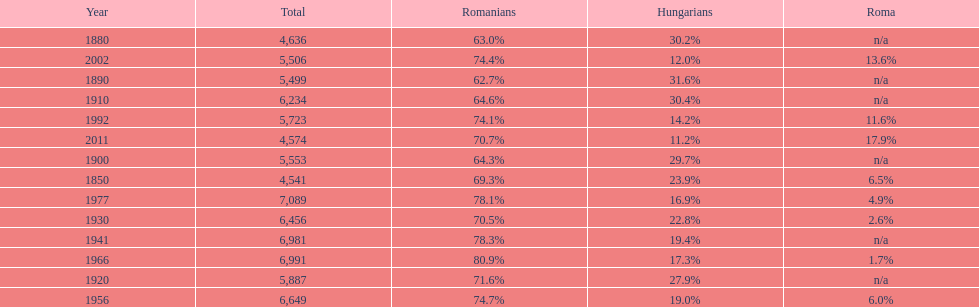Which year witnessed the maximum percentage of hungarians? 1890. Parse the full table. {'header': ['Year', 'Total', 'Romanians', 'Hungarians', 'Roma'], 'rows': [['1880', '4,636', '63.0%', '30.2%', 'n/a'], ['2002', '5,506', '74.4%', '12.0%', '13.6%'], ['1890', '5,499', '62.7%', '31.6%', 'n/a'], ['1910', '6,234', '64.6%', '30.4%', 'n/a'], ['1992', '5,723', '74.1%', '14.2%', '11.6%'], ['2011', '4,574', '70.7%', '11.2%', '17.9%'], ['1900', '5,553', '64.3%', '29.7%', 'n/a'], ['1850', '4,541', '69.3%', '23.9%', '6.5%'], ['1977', '7,089', '78.1%', '16.9%', '4.9%'], ['1930', '6,456', '70.5%', '22.8%', '2.6%'], ['1941', '6,981', '78.3%', '19.4%', 'n/a'], ['1966', '6,991', '80.9%', '17.3%', '1.7%'], ['1920', '5,887', '71.6%', '27.9%', 'n/a'], ['1956', '6,649', '74.7%', '19.0%', '6.0%']]} 